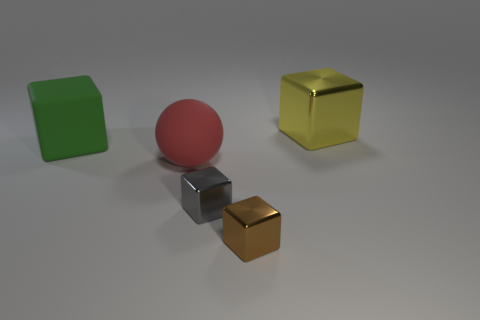Subtract 1 cubes. How many cubes are left? 3 Add 1 purple metal balls. How many objects exist? 6 Subtract all spheres. How many objects are left? 4 Subtract 0 gray spheres. How many objects are left? 5 Subtract all large purple spheres. Subtract all tiny brown metal cubes. How many objects are left? 4 Add 5 tiny brown cubes. How many tiny brown cubes are left? 6 Add 1 big green objects. How many big green objects exist? 2 